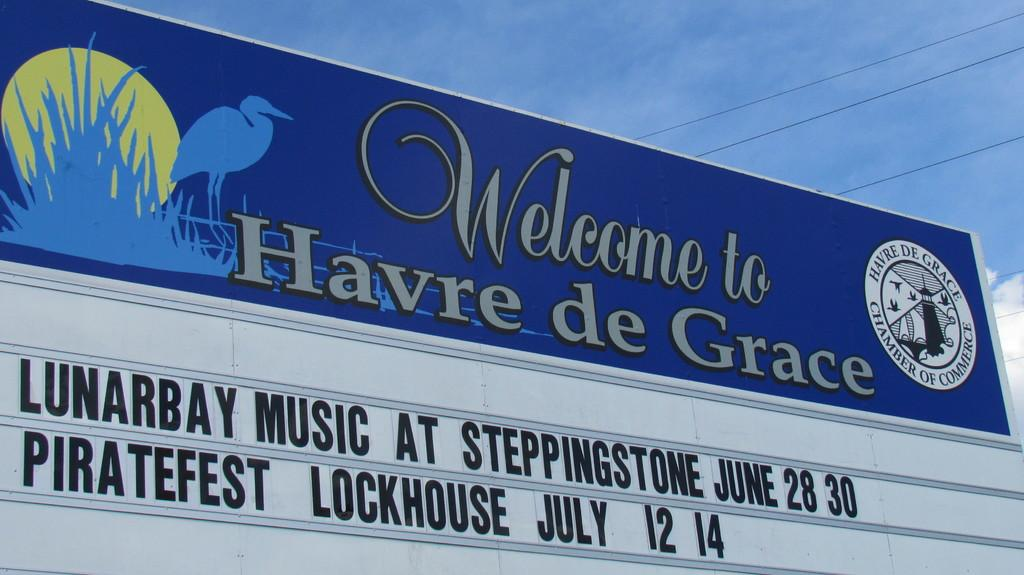<image>
Share a concise interpretation of the image provided. A Welcome sign for the town of Havre de Grace that advertises upcoming events. 